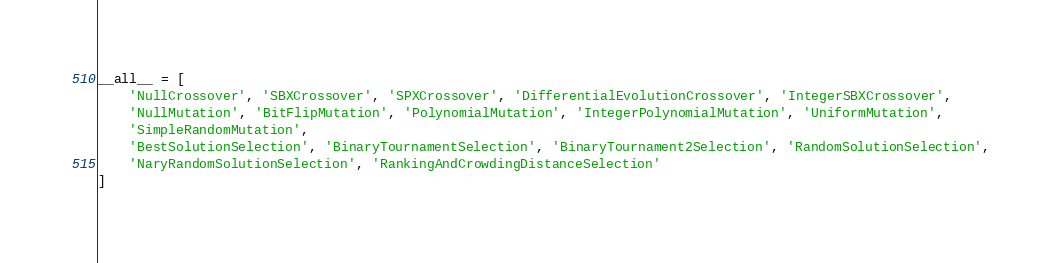Convert code to text. <code><loc_0><loc_0><loc_500><loc_500><_Python_>
__all__ = [
    'NullCrossover', 'SBXCrossover', 'SPXCrossover', 'DifferentialEvolutionCrossover', 'IntegerSBXCrossover',
    'NullMutation', 'BitFlipMutation', 'PolynomialMutation', 'IntegerPolynomialMutation', 'UniformMutation',
    'SimpleRandomMutation',
    'BestSolutionSelection', 'BinaryTournamentSelection', 'BinaryTournament2Selection', 'RandomSolutionSelection',
    'NaryRandomSolutionSelection', 'RankingAndCrowdingDistanceSelection'
]
</code> 